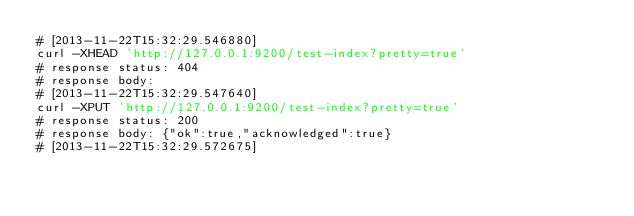<code> <loc_0><loc_0><loc_500><loc_500><_Bash_># [2013-11-22T15:32:29.546880]
curl -XHEAD 'http://127.0.0.1:9200/test-index?pretty=true'
# response status: 404
# response body: 
# [2013-11-22T15:32:29.547640]
curl -XPUT 'http://127.0.0.1:9200/test-index?pretty=true'
# response status: 200
# response body: {"ok":true,"acknowledged":true}
# [2013-11-22T15:32:29.572675]</code> 